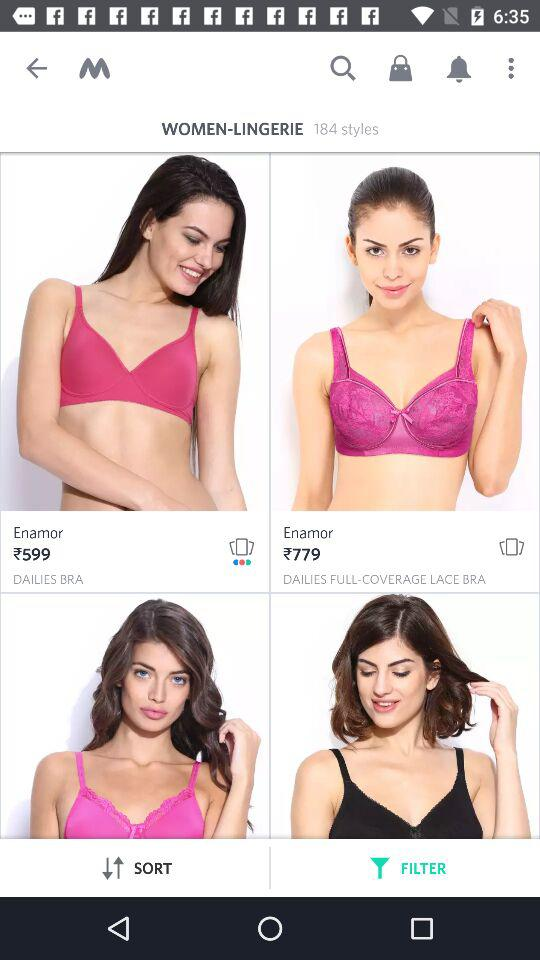How many styles are available in lingerie? There are 184 styles available in lingerie. 